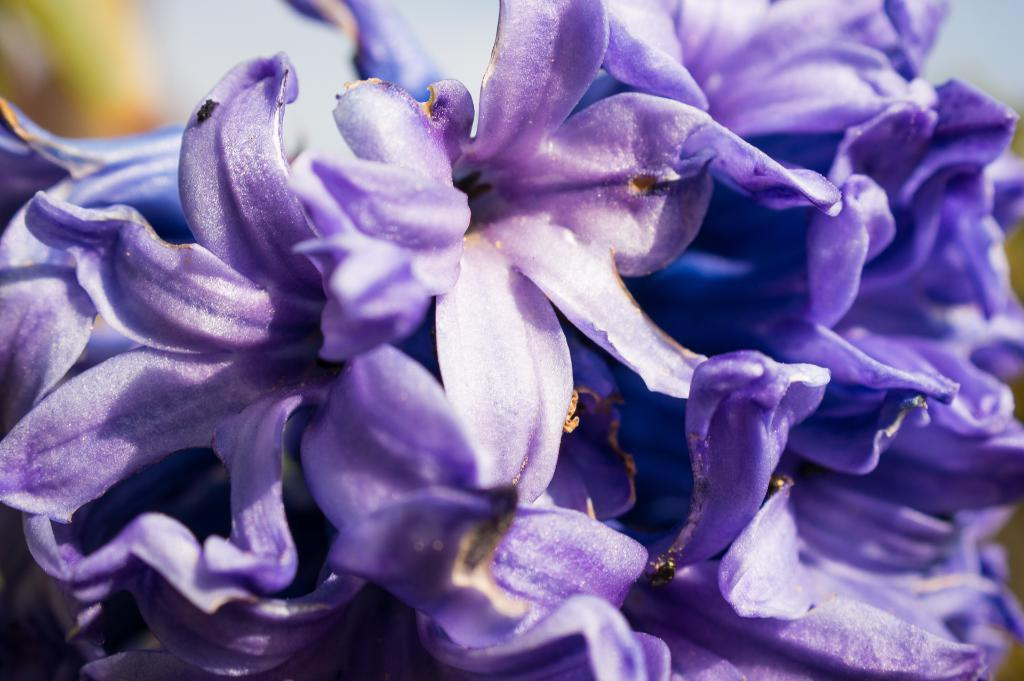What type of plants can be seen in the image? There are flowers in the image. Can you describe the flowers in the image? Unfortunately, the facts provided do not give any details about the flowers' appearance or color. Are the flowers growing in a specific location or setting? The facts provided do not give any information about the flowers' location or setting. What type of mine is depicted in the image? There is no mine present in the image; it only features flowers. 